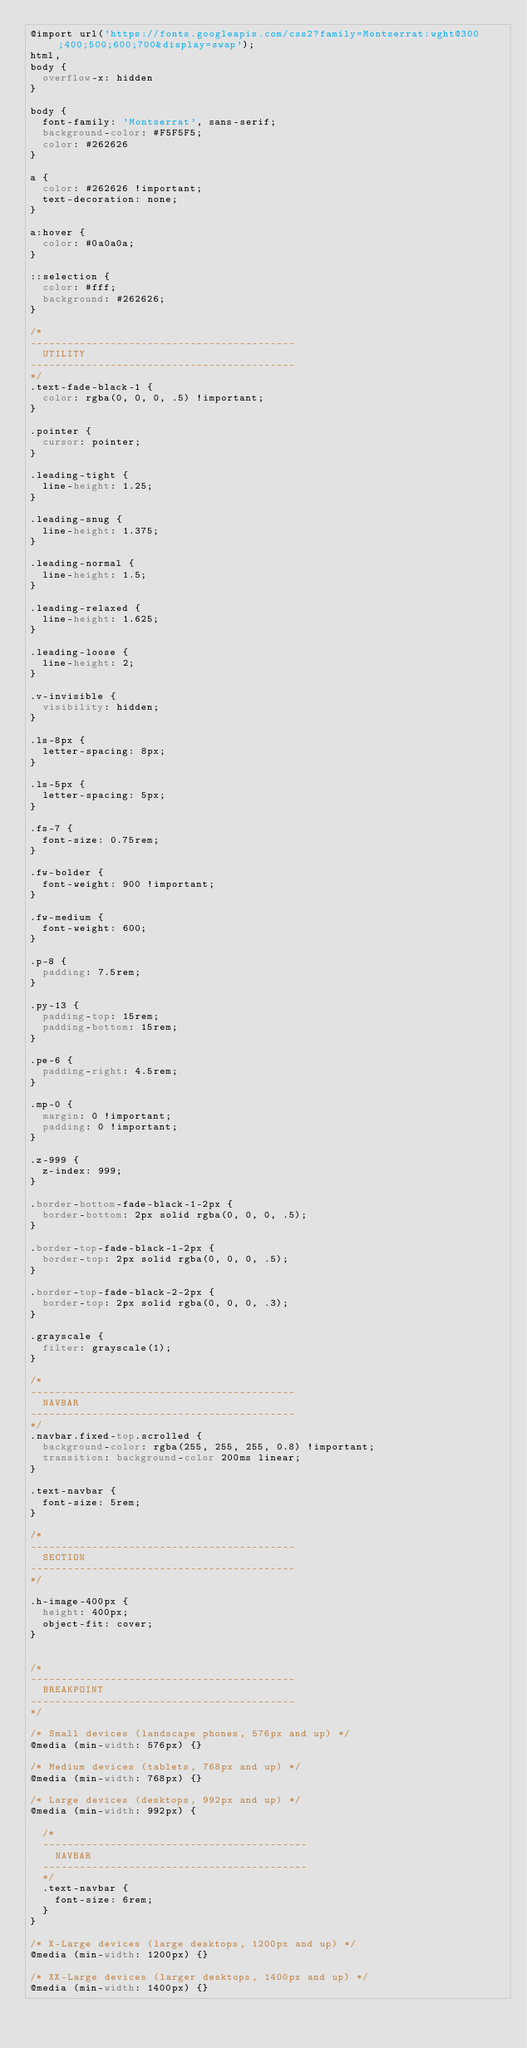Convert code to text. <code><loc_0><loc_0><loc_500><loc_500><_CSS_>@import url('https://fonts.googleapis.com/css2?family=Montserrat:wght@300;400;500;600;700&display=swap');
html,
body {
	overflow-x: hidden
}

body {
	font-family: 'Montserrat', sans-serif;
	background-color: #F5F5F5;
	color: #262626
}

a {
	color: #262626 !important;
	text-decoration: none;
}

a:hover {
	color: #0a0a0a;
}

::selection {
	color: #fff;
	background: #262626;
}

/* 
------------------------------------------- 
	UTILITY 
-------------------------------------------
*/
.text-fade-black-1 {
	color: rgba(0, 0, 0, .5) !important;
}

.pointer {
	cursor: pointer;
}

.leading-tight {
	line-height: 1.25;
}

.leading-snug {
	line-height: 1.375;
}

.leading-normal {
	line-height: 1.5;
}

.leading-relaxed {
	line-height: 1.625;
}

.leading-loose {
	line-height: 2;
}

.v-invisible {
	visibility: hidden;
}

.ls-8px {
	letter-spacing: 8px;
}

.ls-5px {
	letter-spacing: 5px;
}

.fs-7 {
	font-size: 0.75rem;
}

.fw-bolder {
	font-weight: 900 !important;
}

.fw-medium {
	font-weight: 600;
}

.p-8 {
	padding: 7.5rem;
}

.py-13 {
	padding-top: 15rem;
	padding-bottom: 15rem;
}

.pe-6 {
	padding-right: 4.5rem;
}

.mp-0 {
	margin: 0 !important;
	padding: 0 !important;
}

.z-999 {
	z-index: 999;
}

.border-bottom-fade-black-1-2px {
	border-bottom: 2px solid rgba(0, 0, 0, .5);
}

.border-top-fade-black-1-2px {
	border-top: 2px solid rgba(0, 0, 0, .5);
}

.border-top-fade-black-2-2px {
	border-top: 2px solid rgba(0, 0, 0, .3);
}

.grayscale {
	filter: grayscale(1);
}

/* 
------------------------------------------- 
	NAVBAR 
-------------------------------------------
*/
.navbar.fixed-top.scrolled {
	background-color: rgba(255, 255, 255, 0.8) !important;
	transition: background-color 200ms linear;
}

.text-navbar {
	font-size: 5rem;
}

/* 
------------------------------------------- 
	SECTION 
-------------------------------------------
*/

.h-image-400px {
	height: 400px;
	object-fit: cover;
}


/* 
------------------------------------------- 
	BREAKPOINT
-------------------------------------------
*/

/* Small devices (landscape phones, 576px and up) */
@media (min-width: 576px) {}

/* Medium devices (tablets, 768px and up) */
@media (min-width: 768px) {}

/* Large devices (desktops, 992px and up) */
@media (min-width: 992px) {

	/* 
	------------------------------------------- 
		NAVBAR 
	-------------------------------------------
	*/
	.text-navbar {
		font-size: 6rem;
	}
}

/* X-Large devices (large desktops, 1200px and up) */
@media (min-width: 1200px) {}

/* XX-Large devices (larger desktops, 1400px and up) */
@media (min-width: 1400px) {}</code> 